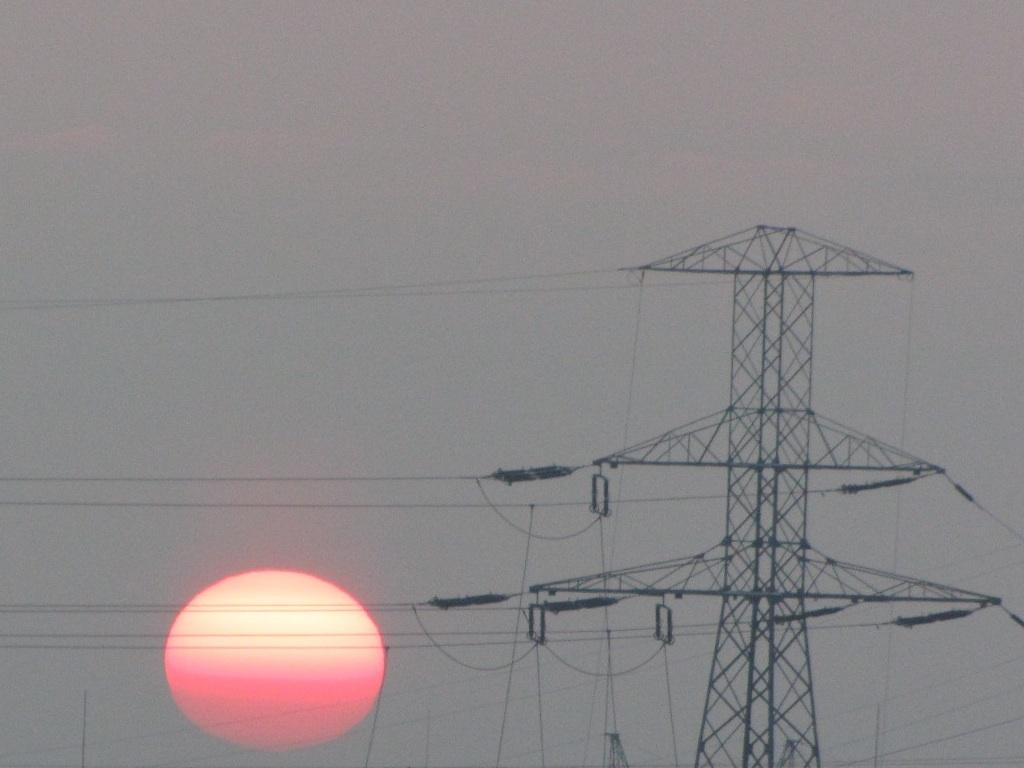What is the main structure in the picture? There is an electric tower in the picture. What is connected to the electric tower? The electric tower has cables attached to it. What is the condition of the sky in the image? The sky is clear in the image. What celestial body can be seen in the sky? The sun is visible in the image. How many eyes can be seen on the electric tower in the image? There are no eyes visible on the electric tower in the image, as it is an inanimate object. 